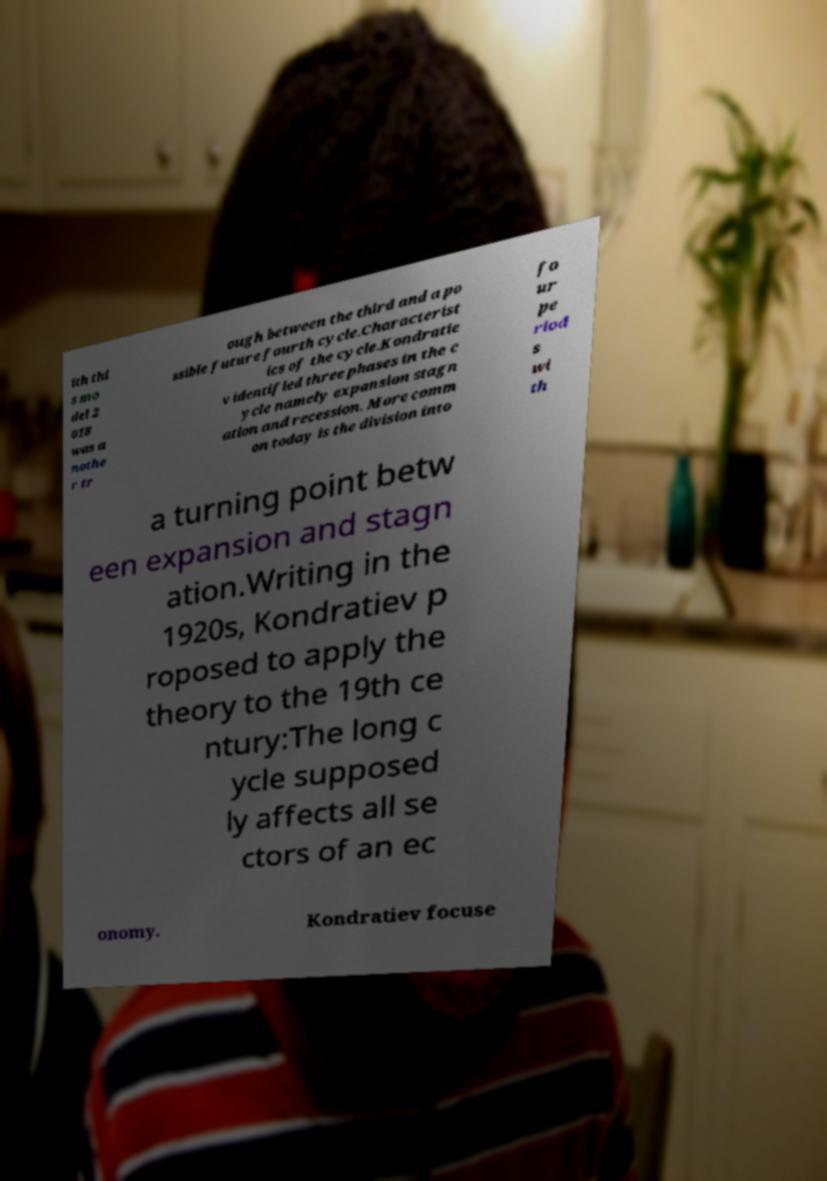Can you read and provide the text displayed in the image?This photo seems to have some interesting text. Can you extract and type it out for me? ith thi s mo del 2 018 was a nothe r tr ough between the third and a po ssible future fourth cycle.Characterist ics of the cycle.Kondratie v identified three phases in the c ycle namely expansion stagn ation and recession. More comm on today is the division into fo ur pe riod s wi th a turning point betw een expansion and stagn ation.Writing in the 1920s, Kondratiev p roposed to apply the theory to the 19th ce ntury:The long c ycle supposed ly affects all se ctors of an ec onomy. Kondratiev focuse 